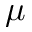Convert formula to latex. <formula><loc_0><loc_0><loc_500><loc_500>\mu</formula> 